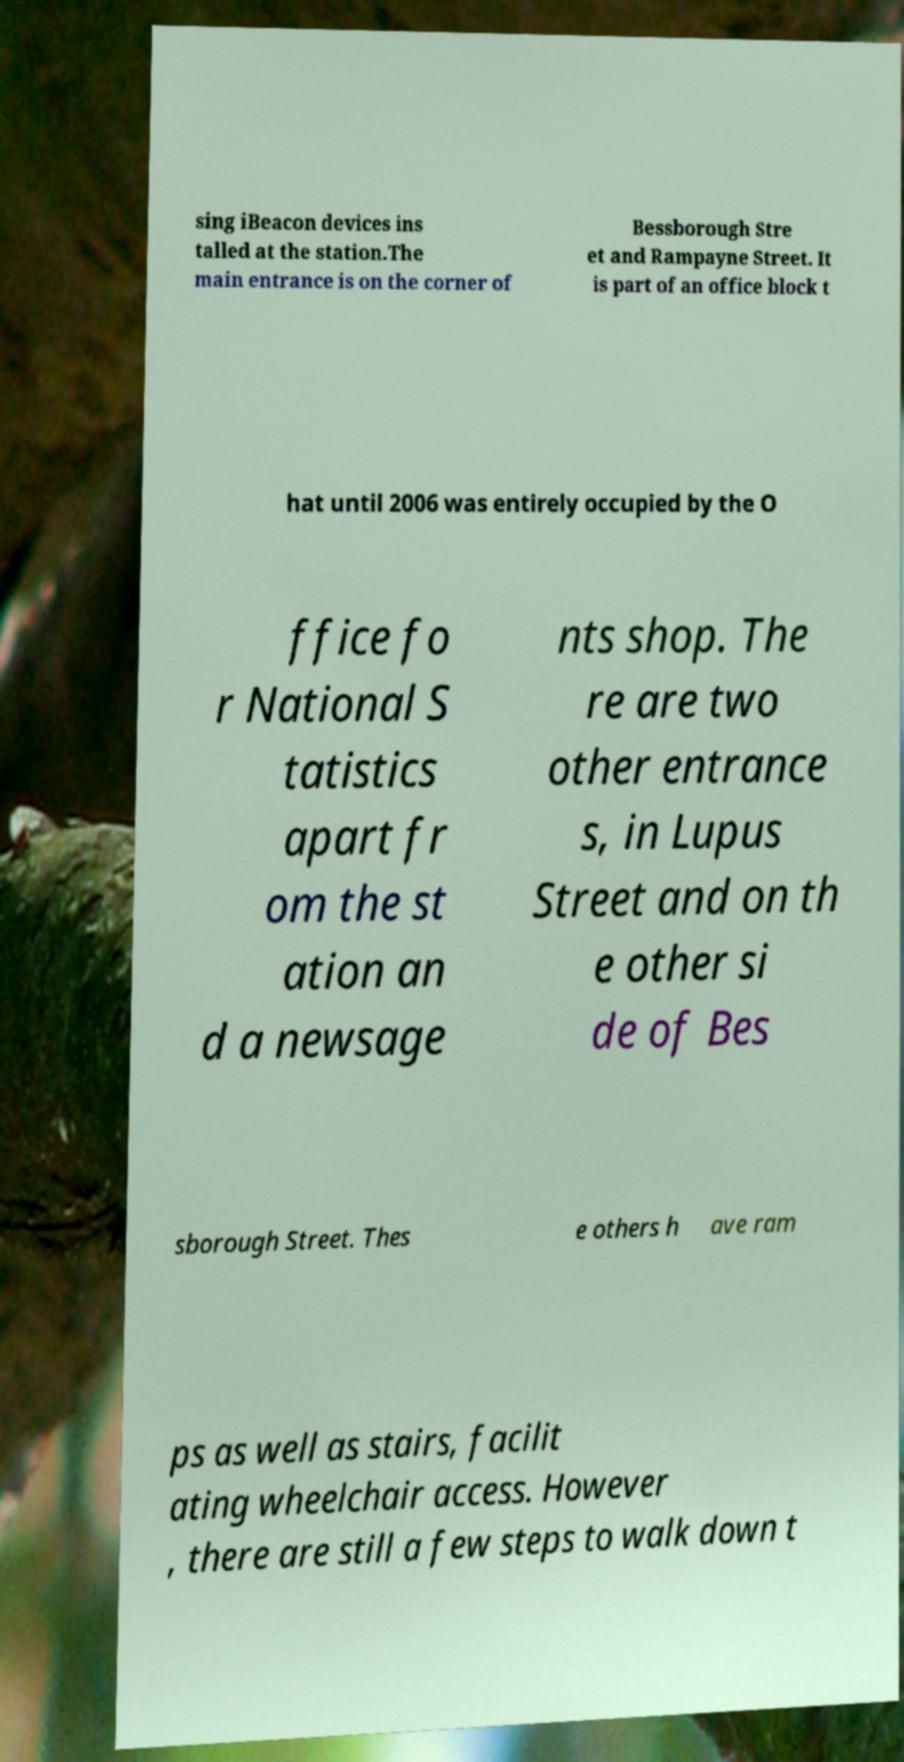For documentation purposes, I need the text within this image transcribed. Could you provide that? sing iBeacon devices ins talled at the station.The main entrance is on the corner of Bessborough Stre et and Rampayne Street. It is part of an office block t hat until 2006 was entirely occupied by the O ffice fo r National S tatistics apart fr om the st ation an d a newsage nts shop. The re are two other entrance s, in Lupus Street and on th e other si de of Bes sborough Street. Thes e others h ave ram ps as well as stairs, facilit ating wheelchair access. However , there are still a few steps to walk down t 